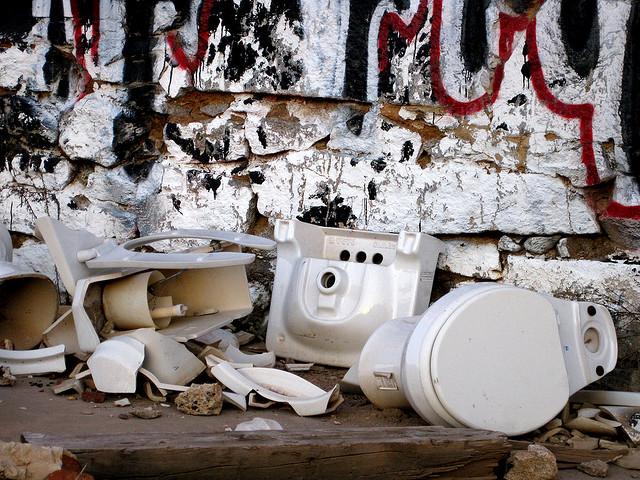What kind of room did these things probably come out of?
Write a very short answer. Bathroom. Are the toilets usable?
Be succinct. No. Which is it black or white?
Concise answer only. White. 